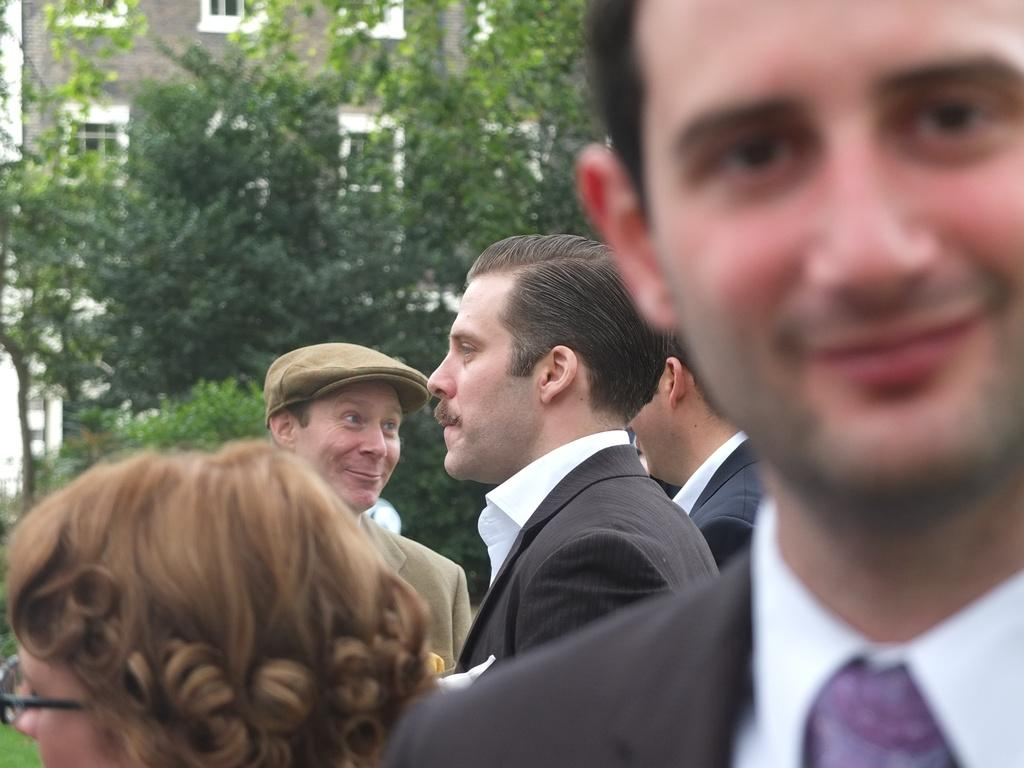How many people are present in the image? There are five persons in the image. What can be seen in the background of the image? There are trees and a building in the background of the image. What type of coil is being used by the persons in the image? There is no coil present in the image; it features five persons and a background with trees and a building. 